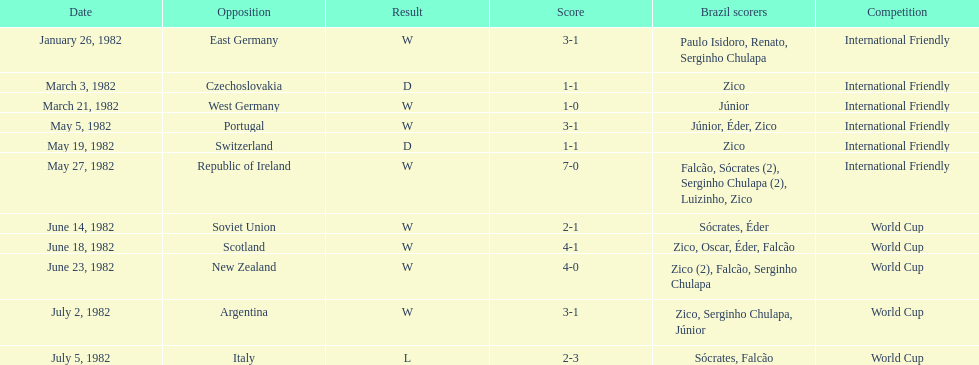How many times did brazil compete against west germany in the 1982 season? 1. 